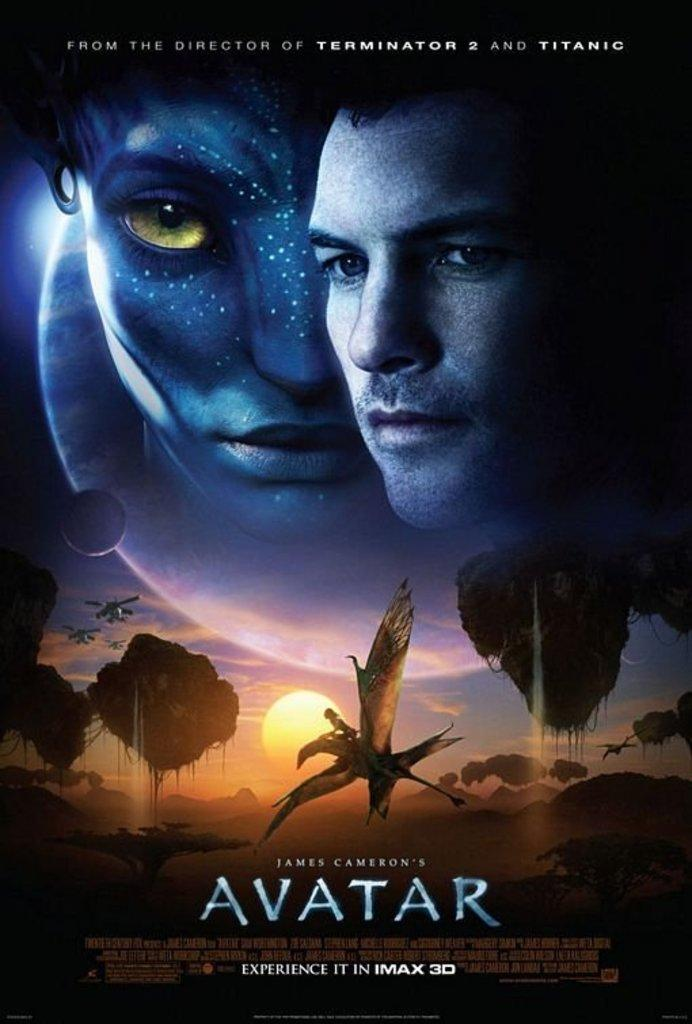<image>
Give a short and clear explanation of the subsequent image. Poster for James Cameron's Avatar showing the faces of the characters. 